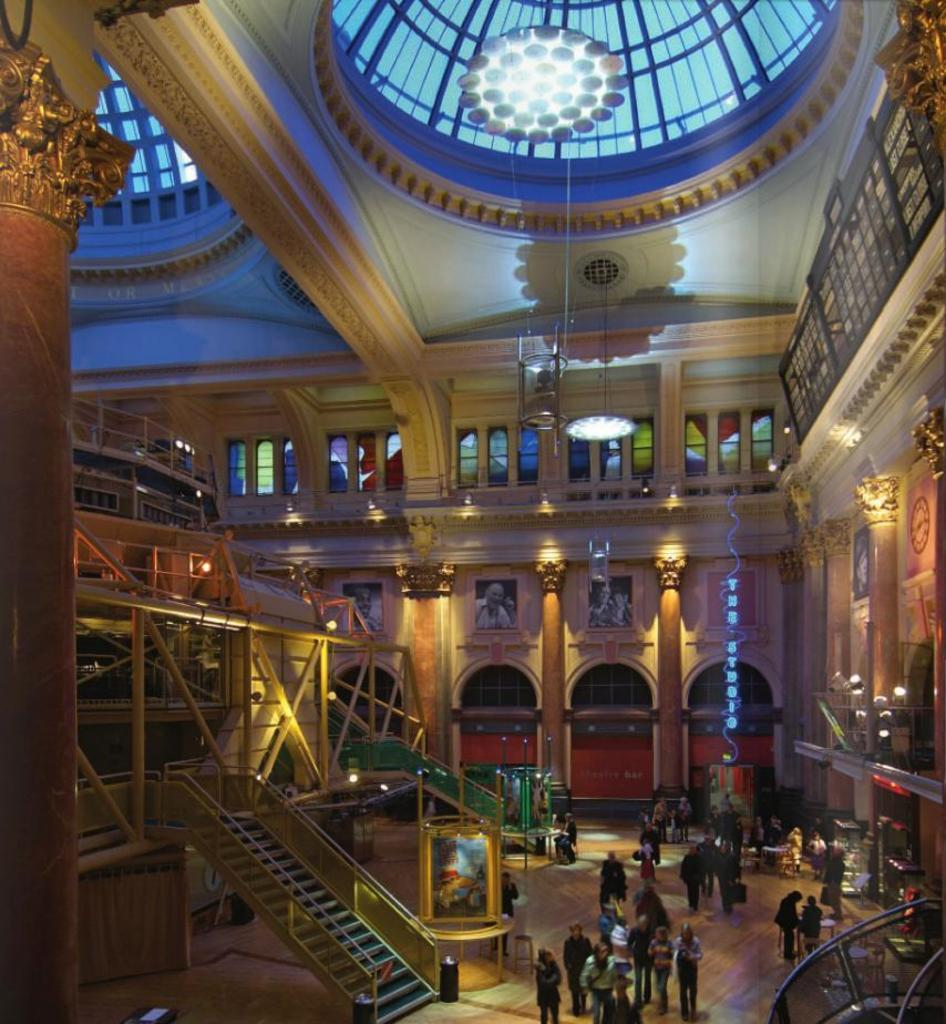What type of location is depicted in the image? The image shows the inside view of a building. What architectural features can be seen in the image? There are pillars, staircases, and poles visible in the image. What type of lighting is present in the image? Lights are present in the image. What type of decorative elements are observable in the image? Frames are visible in the image. What type of surface is present in the image? Boards are present in the image. What part of the building is visible in the image? The ceiling is visible in the image. Are there any people present in the image? Yes, there are people on the floor in the image. What type of collar can be seen on the carpenter in the image? There is no carpenter present in the image, and therefore no collar can be seen. 